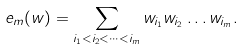Convert formula to latex. <formula><loc_0><loc_0><loc_500><loc_500>e _ { m } ( w ) = \sum _ { i _ { 1 } < i _ { 2 } < \cdots < i _ { m } } w _ { i _ { 1 } } w _ { i _ { 2 } } \dots w _ { i _ { m } } .</formula> 